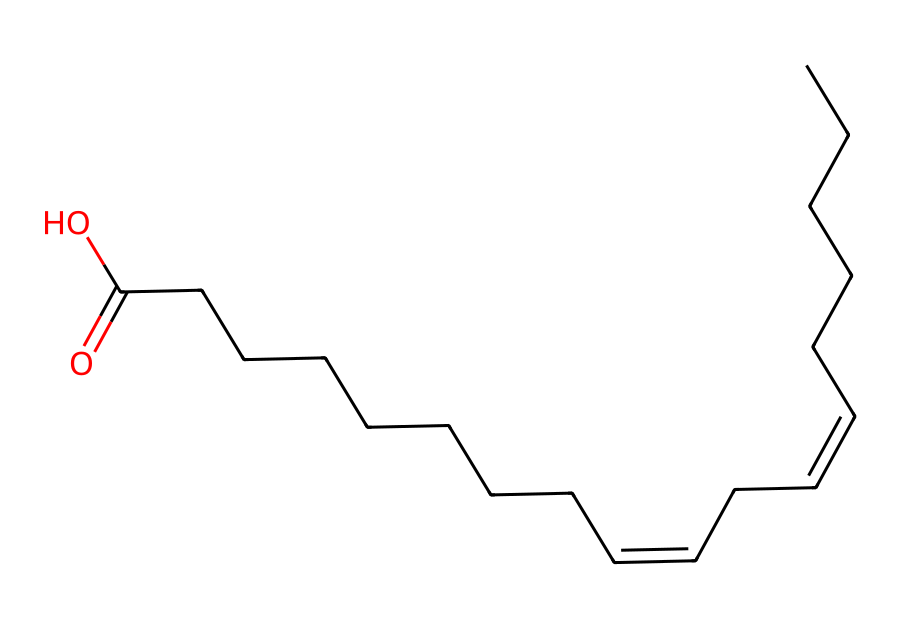What type of isomerism is displayed in this chemical? The structure contains double bonds (C=C) with different substituents on either side, which is characteristic of cis-trans isomerism.
Answer: cis-trans isomerism How many carbon atoms are in this structure? By counting the 'C' characters in the SMILES representation, there are 20 carbon atoms represented in the chain.
Answer: 20 What is the functional group present in this chemical? The presence of the -COOH group (indicated by the "=O" and "O" at the end of the SMILES) confirms that the chemical has a carboxylic acid functional group.
Answer: carboxylic acid How many double bonds are present in this molecule? The SMILES notation includes two "/C=C/" sections, indicating there are two double bonds in the structure.
Answer: 2 Is this compound likely to be a solid or liquid at room temperature? The presence of long hydrocarbon chains generally suggests that it would be a liquid at room temperature, typical for many natural plant-based solvents.
Answer: liquid What geometric arrangement would result from a cis configuration in this chemical? In a cis configuration, the bulky groups attached to the double bond would be on the same side, leading to a bent shape, affecting solubility and volatility.
Answer: bent shape How does the presence of cis-trans isomerism affect the properties of this solvent? The spatial arrangement of substituents changes physical properties like boiling point and solubility; cis isomers often have higher boiling points due to polar interactions.
Answer: changes boiling point and solubility 